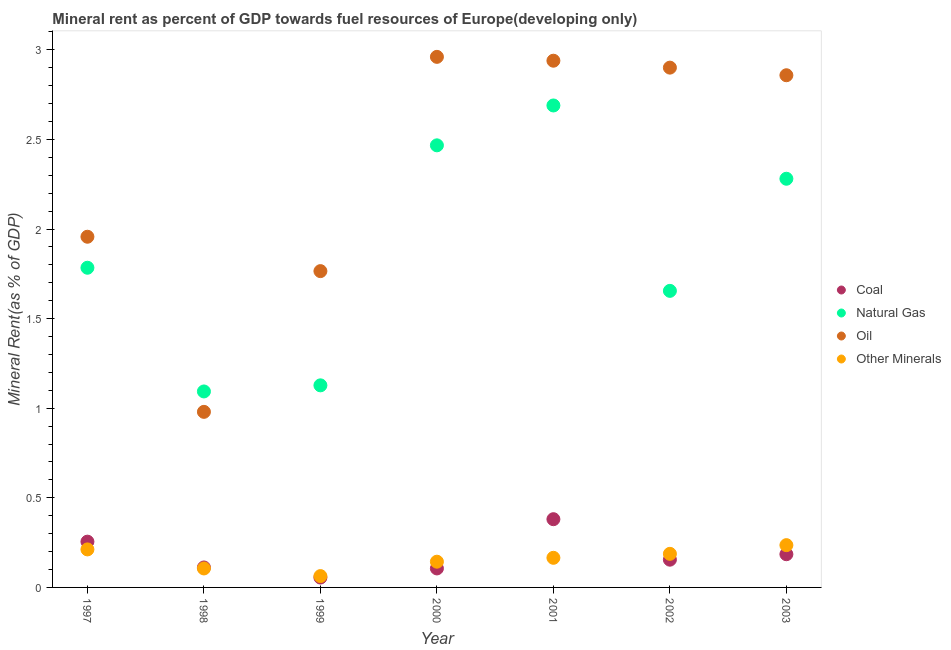How many different coloured dotlines are there?
Your answer should be very brief. 4. Is the number of dotlines equal to the number of legend labels?
Keep it short and to the point. Yes. What is the natural gas rent in 1999?
Offer a very short reply. 1.13. Across all years, what is the maximum coal rent?
Keep it short and to the point. 0.38. Across all years, what is the minimum coal rent?
Your response must be concise. 0.06. In which year was the natural gas rent maximum?
Your answer should be very brief. 2001. What is the total natural gas rent in the graph?
Ensure brevity in your answer.  13.1. What is the difference between the coal rent in 1998 and that in 2001?
Your response must be concise. -0.27. What is the difference between the coal rent in 1999 and the natural gas rent in 2002?
Your answer should be very brief. -1.6. What is the average coal rent per year?
Your response must be concise. 0.18. In the year 2002, what is the difference between the coal rent and oil rent?
Ensure brevity in your answer.  -2.75. In how many years, is the oil rent greater than 0.2 %?
Your answer should be very brief. 7. What is the ratio of the natural gas rent in 1999 to that in 2001?
Offer a very short reply. 0.42. Is the difference between the coal rent in 1998 and 2002 greater than the difference between the oil rent in 1998 and 2002?
Offer a very short reply. Yes. What is the difference between the highest and the second highest natural gas rent?
Provide a succinct answer. 0.22. What is the difference between the highest and the lowest  rent of other minerals?
Your response must be concise. 0.17. Is it the case that in every year, the sum of the coal rent and natural gas rent is greater than the sum of oil rent and  rent of other minerals?
Provide a succinct answer. No. Does the coal rent monotonically increase over the years?
Offer a terse response. No. What is the difference between two consecutive major ticks on the Y-axis?
Make the answer very short. 0.5. Are the values on the major ticks of Y-axis written in scientific E-notation?
Provide a succinct answer. No. Does the graph contain any zero values?
Offer a terse response. No. What is the title of the graph?
Keep it short and to the point. Mineral rent as percent of GDP towards fuel resources of Europe(developing only). Does "Agriculture" appear as one of the legend labels in the graph?
Your answer should be compact. No. What is the label or title of the X-axis?
Offer a very short reply. Year. What is the label or title of the Y-axis?
Provide a succinct answer. Mineral Rent(as % of GDP). What is the Mineral Rent(as % of GDP) of Coal in 1997?
Provide a short and direct response. 0.26. What is the Mineral Rent(as % of GDP) in Natural Gas in 1997?
Your answer should be compact. 1.78. What is the Mineral Rent(as % of GDP) in Oil in 1997?
Keep it short and to the point. 1.96. What is the Mineral Rent(as % of GDP) in Other Minerals in 1997?
Your response must be concise. 0.21. What is the Mineral Rent(as % of GDP) in Coal in 1998?
Provide a succinct answer. 0.11. What is the Mineral Rent(as % of GDP) in Natural Gas in 1998?
Ensure brevity in your answer.  1.09. What is the Mineral Rent(as % of GDP) in Oil in 1998?
Offer a very short reply. 0.98. What is the Mineral Rent(as % of GDP) of Other Minerals in 1998?
Your answer should be compact. 0.11. What is the Mineral Rent(as % of GDP) in Coal in 1999?
Your answer should be compact. 0.06. What is the Mineral Rent(as % of GDP) in Natural Gas in 1999?
Ensure brevity in your answer.  1.13. What is the Mineral Rent(as % of GDP) in Oil in 1999?
Ensure brevity in your answer.  1.77. What is the Mineral Rent(as % of GDP) of Other Minerals in 1999?
Make the answer very short. 0.06. What is the Mineral Rent(as % of GDP) of Coal in 2000?
Your answer should be compact. 0.11. What is the Mineral Rent(as % of GDP) in Natural Gas in 2000?
Ensure brevity in your answer.  2.47. What is the Mineral Rent(as % of GDP) in Oil in 2000?
Ensure brevity in your answer.  2.96. What is the Mineral Rent(as % of GDP) in Other Minerals in 2000?
Offer a terse response. 0.14. What is the Mineral Rent(as % of GDP) in Coal in 2001?
Make the answer very short. 0.38. What is the Mineral Rent(as % of GDP) in Natural Gas in 2001?
Your answer should be very brief. 2.69. What is the Mineral Rent(as % of GDP) of Oil in 2001?
Offer a terse response. 2.94. What is the Mineral Rent(as % of GDP) in Other Minerals in 2001?
Your response must be concise. 0.17. What is the Mineral Rent(as % of GDP) in Coal in 2002?
Provide a short and direct response. 0.15. What is the Mineral Rent(as % of GDP) in Natural Gas in 2002?
Keep it short and to the point. 1.65. What is the Mineral Rent(as % of GDP) of Oil in 2002?
Offer a terse response. 2.9. What is the Mineral Rent(as % of GDP) in Other Minerals in 2002?
Ensure brevity in your answer.  0.19. What is the Mineral Rent(as % of GDP) of Coal in 2003?
Offer a terse response. 0.19. What is the Mineral Rent(as % of GDP) of Natural Gas in 2003?
Give a very brief answer. 2.28. What is the Mineral Rent(as % of GDP) of Oil in 2003?
Provide a short and direct response. 2.86. What is the Mineral Rent(as % of GDP) of Other Minerals in 2003?
Your response must be concise. 0.24. Across all years, what is the maximum Mineral Rent(as % of GDP) of Coal?
Make the answer very short. 0.38. Across all years, what is the maximum Mineral Rent(as % of GDP) in Natural Gas?
Offer a terse response. 2.69. Across all years, what is the maximum Mineral Rent(as % of GDP) of Oil?
Give a very brief answer. 2.96. Across all years, what is the maximum Mineral Rent(as % of GDP) in Other Minerals?
Your answer should be very brief. 0.24. Across all years, what is the minimum Mineral Rent(as % of GDP) of Coal?
Your answer should be very brief. 0.06. Across all years, what is the minimum Mineral Rent(as % of GDP) in Natural Gas?
Offer a terse response. 1.09. Across all years, what is the minimum Mineral Rent(as % of GDP) of Oil?
Your answer should be very brief. 0.98. Across all years, what is the minimum Mineral Rent(as % of GDP) of Other Minerals?
Provide a short and direct response. 0.06. What is the total Mineral Rent(as % of GDP) of Coal in the graph?
Your response must be concise. 1.25. What is the total Mineral Rent(as % of GDP) of Natural Gas in the graph?
Your answer should be very brief. 13.1. What is the total Mineral Rent(as % of GDP) of Oil in the graph?
Ensure brevity in your answer.  16.36. What is the total Mineral Rent(as % of GDP) of Other Minerals in the graph?
Offer a terse response. 1.11. What is the difference between the Mineral Rent(as % of GDP) in Coal in 1997 and that in 1998?
Provide a succinct answer. 0.14. What is the difference between the Mineral Rent(as % of GDP) in Natural Gas in 1997 and that in 1998?
Your response must be concise. 0.69. What is the difference between the Mineral Rent(as % of GDP) of Oil in 1997 and that in 1998?
Offer a very short reply. 0.98. What is the difference between the Mineral Rent(as % of GDP) in Other Minerals in 1997 and that in 1998?
Your answer should be compact. 0.11. What is the difference between the Mineral Rent(as % of GDP) in Coal in 1997 and that in 1999?
Keep it short and to the point. 0.2. What is the difference between the Mineral Rent(as % of GDP) of Natural Gas in 1997 and that in 1999?
Offer a terse response. 0.66. What is the difference between the Mineral Rent(as % of GDP) in Oil in 1997 and that in 1999?
Make the answer very short. 0.19. What is the difference between the Mineral Rent(as % of GDP) in Other Minerals in 1997 and that in 1999?
Your answer should be compact. 0.15. What is the difference between the Mineral Rent(as % of GDP) in Coal in 1997 and that in 2000?
Ensure brevity in your answer.  0.15. What is the difference between the Mineral Rent(as % of GDP) of Natural Gas in 1997 and that in 2000?
Keep it short and to the point. -0.68. What is the difference between the Mineral Rent(as % of GDP) in Oil in 1997 and that in 2000?
Offer a very short reply. -1. What is the difference between the Mineral Rent(as % of GDP) of Other Minerals in 1997 and that in 2000?
Your answer should be very brief. 0.07. What is the difference between the Mineral Rent(as % of GDP) of Coal in 1997 and that in 2001?
Make the answer very short. -0.13. What is the difference between the Mineral Rent(as % of GDP) of Natural Gas in 1997 and that in 2001?
Make the answer very short. -0.91. What is the difference between the Mineral Rent(as % of GDP) in Oil in 1997 and that in 2001?
Provide a short and direct response. -0.98. What is the difference between the Mineral Rent(as % of GDP) of Other Minerals in 1997 and that in 2001?
Offer a terse response. 0.05. What is the difference between the Mineral Rent(as % of GDP) of Coal in 1997 and that in 2002?
Your answer should be very brief. 0.1. What is the difference between the Mineral Rent(as % of GDP) of Natural Gas in 1997 and that in 2002?
Your response must be concise. 0.13. What is the difference between the Mineral Rent(as % of GDP) of Oil in 1997 and that in 2002?
Ensure brevity in your answer.  -0.94. What is the difference between the Mineral Rent(as % of GDP) of Other Minerals in 1997 and that in 2002?
Provide a short and direct response. 0.02. What is the difference between the Mineral Rent(as % of GDP) in Coal in 1997 and that in 2003?
Keep it short and to the point. 0.07. What is the difference between the Mineral Rent(as % of GDP) of Natural Gas in 1997 and that in 2003?
Your response must be concise. -0.5. What is the difference between the Mineral Rent(as % of GDP) of Oil in 1997 and that in 2003?
Offer a very short reply. -0.9. What is the difference between the Mineral Rent(as % of GDP) of Other Minerals in 1997 and that in 2003?
Offer a terse response. -0.02. What is the difference between the Mineral Rent(as % of GDP) of Coal in 1998 and that in 1999?
Your answer should be very brief. 0.06. What is the difference between the Mineral Rent(as % of GDP) in Natural Gas in 1998 and that in 1999?
Provide a succinct answer. -0.03. What is the difference between the Mineral Rent(as % of GDP) in Oil in 1998 and that in 1999?
Provide a succinct answer. -0.79. What is the difference between the Mineral Rent(as % of GDP) in Other Minerals in 1998 and that in 1999?
Make the answer very short. 0.04. What is the difference between the Mineral Rent(as % of GDP) of Coal in 1998 and that in 2000?
Your answer should be very brief. 0.01. What is the difference between the Mineral Rent(as % of GDP) of Natural Gas in 1998 and that in 2000?
Keep it short and to the point. -1.37. What is the difference between the Mineral Rent(as % of GDP) in Oil in 1998 and that in 2000?
Your answer should be compact. -1.98. What is the difference between the Mineral Rent(as % of GDP) of Other Minerals in 1998 and that in 2000?
Offer a terse response. -0.04. What is the difference between the Mineral Rent(as % of GDP) in Coal in 1998 and that in 2001?
Your answer should be very brief. -0.27. What is the difference between the Mineral Rent(as % of GDP) of Natural Gas in 1998 and that in 2001?
Your response must be concise. -1.6. What is the difference between the Mineral Rent(as % of GDP) in Oil in 1998 and that in 2001?
Offer a very short reply. -1.96. What is the difference between the Mineral Rent(as % of GDP) of Other Minerals in 1998 and that in 2001?
Provide a succinct answer. -0.06. What is the difference between the Mineral Rent(as % of GDP) of Coal in 1998 and that in 2002?
Offer a very short reply. -0.04. What is the difference between the Mineral Rent(as % of GDP) in Natural Gas in 1998 and that in 2002?
Give a very brief answer. -0.56. What is the difference between the Mineral Rent(as % of GDP) of Oil in 1998 and that in 2002?
Give a very brief answer. -1.92. What is the difference between the Mineral Rent(as % of GDP) of Other Minerals in 1998 and that in 2002?
Provide a succinct answer. -0.08. What is the difference between the Mineral Rent(as % of GDP) of Coal in 1998 and that in 2003?
Your response must be concise. -0.07. What is the difference between the Mineral Rent(as % of GDP) in Natural Gas in 1998 and that in 2003?
Provide a short and direct response. -1.19. What is the difference between the Mineral Rent(as % of GDP) of Oil in 1998 and that in 2003?
Give a very brief answer. -1.88. What is the difference between the Mineral Rent(as % of GDP) in Other Minerals in 1998 and that in 2003?
Offer a very short reply. -0.13. What is the difference between the Mineral Rent(as % of GDP) of Coal in 1999 and that in 2000?
Provide a short and direct response. -0.05. What is the difference between the Mineral Rent(as % of GDP) in Natural Gas in 1999 and that in 2000?
Your answer should be compact. -1.34. What is the difference between the Mineral Rent(as % of GDP) of Oil in 1999 and that in 2000?
Offer a very short reply. -1.2. What is the difference between the Mineral Rent(as % of GDP) of Other Minerals in 1999 and that in 2000?
Your answer should be compact. -0.08. What is the difference between the Mineral Rent(as % of GDP) in Coal in 1999 and that in 2001?
Ensure brevity in your answer.  -0.33. What is the difference between the Mineral Rent(as % of GDP) in Natural Gas in 1999 and that in 2001?
Give a very brief answer. -1.56. What is the difference between the Mineral Rent(as % of GDP) of Oil in 1999 and that in 2001?
Offer a terse response. -1.17. What is the difference between the Mineral Rent(as % of GDP) in Other Minerals in 1999 and that in 2001?
Your answer should be compact. -0.1. What is the difference between the Mineral Rent(as % of GDP) in Coal in 1999 and that in 2002?
Give a very brief answer. -0.1. What is the difference between the Mineral Rent(as % of GDP) in Natural Gas in 1999 and that in 2002?
Provide a succinct answer. -0.53. What is the difference between the Mineral Rent(as % of GDP) of Oil in 1999 and that in 2002?
Your response must be concise. -1.14. What is the difference between the Mineral Rent(as % of GDP) in Other Minerals in 1999 and that in 2002?
Provide a succinct answer. -0.12. What is the difference between the Mineral Rent(as % of GDP) of Coal in 1999 and that in 2003?
Your answer should be very brief. -0.13. What is the difference between the Mineral Rent(as % of GDP) in Natural Gas in 1999 and that in 2003?
Your answer should be compact. -1.15. What is the difference between the Mineral Rent(as % of GDP) of Oil in 1999 and that in 2003?
Your response must be concise. -1.09. What is the difference between the Mineral Rent(as % of GDP) in Other Minerals in 1999 and that in 2003?
Your response must be concise. -0.17. What is the difference between the Mineral Rent(as % of GDP) in Coal in 2000 and that in 2001?
Your answer should be compact. -0.27. What is the difference between the Mineral Rent(as % of GDP) of Natural Gas in 2000 and that in 2001?
Your response must be concise. -0.22. What is the difference between the Mineral Rent(as % of GDP) in Oil in 2000 and that in 2001?
Offer a very short reply. 0.02. What is the difference between the Mineral Rent(as % of GDP) of Other Minerals in 2000 and that in 2001?
Ensure brevity in your answer.  -0.02. What is the difference between the Mineral Rent(as % of GDP) of Coal in 2000 and that in 2002?
Offer a terse response. -0.05. What is the difference between the Mineral Rent(as % of GDP) of Natural Gas in 2000 and that in 2002?
Provide a succinct answer. 0.81. What is the difference between the Mineral Rent(as % of GDP) of Oil in 2000 and that in 2002?
Your answer should be very brief. 0.06. What is the difference between the Mineral Rent(as % of GDP) in Other Minerals in 2000 and that in 2002?
Your answer should be compact. -0.04. What is the difference between the Mineral Rent(as % of GDP) of Coal in 2000 and that in 2003?
Make the answer very short. -0.08. What is the difference between the Mineral Rent(as % of GDP) in Natural Gas in 2000 and that in 2003?
Offer a terse response. 0.19. What is the difference between the Mineral Rent(as % of GDP) of Oil in 2000 and that in 2003?
Provide a short and direct response. 0.1. What is the difference between the Mineral Rent(as % of GDP) in Other Minerals in 2000 and that in 2003?
Ensure brevity in your answer.  -0.09. What is the difference between the Mineral Rent(as % of GDP) in Coal in 2001 and that in 2002?
Keep it short and to the point. 0.23. What is the difference between the Mineral Rent(as % of GDP) in Natural Gas in 2001 and that in 2002?
Keep it short and to the point. 1.03. What is the difference between the Mineral Rent(as % of GDP) in Oil in 2001 and that in 2002?
Provide a succinct answer. 0.04. What is the difference between the Mineral Rent(as % of GDP) in Other Minerals in 2001 and that in 2002?
Provide a succinct answer. -0.02. What is the difference between the Mineral Rent(as % of GDP) in Coal in 2001 and that in 2003?
Offer a terse response. 0.2. What is the difference between the Mineral Rent(as % of GDP) of Natural Gas in 2001 and that in 2003?
Keep it short and to the point. 0.41. What is the difference between the Mineral Rent(as % of GDP) of Oil in 2001 and that in 2003?
Make the answer very short. 0.08. What is the difference between the Mineral Rent(as % of GDP) in Other Minerals in 2001 and that in 2003?
Provide a succinct answer. -0.07. What is the difference between the Mineral Rent(as % of GDP) of Coal in 2002 and that in 2003?
Your response must be concise. -0.03. What is the difference between the Mineral Rent(as % of GDP) of Natural Gas in 2002 and that in 2003?
Your answer should be very brief. -0.63. What is the difference between the Mineral Rent(as % of GDP) in Oil in 2002 and that in 2003?
Your answer should be very brief. 0.04. What is the difference between the Mineral Rent(as % of GDP) in Other Minerals in 2002 and that in 2003?
Offer a terse response. -0.05. What is the difference between the Mineral Rent(as % of GDP) in Coal in 1997 and the Mineral Rent(as % of GDP) in Natural Gas in 1998?
Offer a very short reply. -0.84. What is the difference between the Mineral Rent(as % of GDP) in Coal in 1997 and the Mineral Rent(as % of GDP) in Oil in 1998?
Provide a succinct answer. -0.72. What is the difference between the Mineral Rent(as % of GDP) in Coal in 1997 and the Mineral Rent(as % of GDP) in Other Minerals in 1998?
Provide a succinct answer. 0.15. What is the difference between the Mineral Rent(as % of GDP) in Natural Gas in 1997 and the Mineral Rent(as % of GDP) in Oil in 1998?
Offer a very short reply. 0.8. What is the difference between the Mineral Rent(as % of GDP) in Natural Gas in 1997 and the Mineral Rent(as % of GDP) in Other Minerals in 1998?
Your answer should be very brief. 1.68. What is the difference between the Mineral Rent(as % of GDP) of Oil in 1997 and the Mineral Rent(as % of GDP) of Other Minerals in 1998?
Offer a terse response. 1.85. What is the difference between the Mineral Rent(as % of GDP) in Coal in 1997 and the Mineral Rent(as % of GDP) in Natural Gas in 1999?
Provide a succinct answer. -0.87. What is the difference between the Mineral Rent(as % of GDP) of Coal in 1997 and the Mineral Rent(as % of GDP) of Oil in 1999?
Ensure brevity in your answer.  -1.51. What is the difference between the Mineral Rent(as % of GDP) in Coal in 1997 and the Mineral Rent(as % of GDP) in Other Minerals in 1999?
Give a very brief answer. 0.19. What is the difference between the Mineral Rent(as % of GDP) of Natural Gas in 1997 and the Mineral Rent(as % of GDP) of Oil in 1999?
Your response must be concise. 0.02. What is the difference between the Mineral Rent(as % of GDP) in Natural Gas in 1997 and the Mineral Rent(as % of GDP) in Other Minerals in 1999?
Provide a succinct answer. 1.72. What is the difference between the Mineral Rent(as % of GDP) in Oil in 1997 and the Mineral Rent(as % of GDP) in Other Minerals in 1999?
Ensure brevity in your answer.  1.89. What is the difference between the Mineral Rent(as % of GDP) of Coal in 1997 and the Mineral Rent(as % of GDP) of Natural Gas in 2000?
Give a very brief answer. -2.21. What is the difference between the Mineral Rent(as % of GDP) in Coal in 1997 and the Mineral Rent(as % of GDP) in Oil in 2000?
Offer a terse response. -2.71. What is the difference between the Mineral Rent(as % of GDP) of Coal in 1997 and the Mineral Rent(as % of GDP) of Other Minerals in 2000?
Your answer should be very brief. 0.11. What is the difference between the Mineral Rent(as % of GDP) in Natural Gas in 1997 and the Mineral Rent(as % of GDP) in Oil in 2000?
Your answer should be very brief. -1.18. What is the difference between the Mineral Rent(as % of GDP) in Natural Gas in 1997 and the Mineral Rent(as % of GDP) in Other Minerals in 2000?
Provide a succinct answer. 1.64. What is the difference between the Mineral Rent(as % of GDP) of Oil in 1997 and the Mineral Rent(as % of GDP) of Other Minerals in 2000?
Your answer should be very brief. 1.81. What is the difference between the Mineral Rent(as % of GDP) of Coal in 1997 and the Mineral Rent(as % of GDP) of Natural Gas in 2001?
Provide a short and direct response. -2.43. What is the difference between the Mineral Rent(as % of GDP) of Coal in 1997 and the Mineral Rent(as % of GDP) of Oil in 2001?
Your response must be concise. -2.68. What is the difference between the Mineral Rent(as % of GDP) in Coal in 1997 and the Mineral Rent(as % of GDP) in Other Minerals in 2001?
Give a very brief answer. 0.09. What is the difference between the Mineral Rent(as % of GDP) of Natural Gas in 1997 and the Mineral Rent(as % of GDP) of Oil in 2001?
Your answer should be very brief. -1.16. What is the difference between the Mineral Rent(as % of GDP) of Natural Gas in 1997 and the Mineral Rent(as % of GDP) of Other Minerals in 2001?
Your answer should be compact. 1.62. What is the difference between the Mineral Rent(as % of GDP) of Oil in 1997 and the Mineral Rent(as % of GDP) of Other Minerals in 2001?
Provide a short and direct response. 1.79. What is the difference between the Mineral Rent(as % of GDP) of Coal in 1997 and the Mineral Rent(as % of GDP) of Natural Gas in 2002?
Offer a terse response. -1.4. What is the difference between the Mineral Rent(as % of GDP) of Coal in 1997 and the Mineral Rent(as % of GDP) of Oil in 2002?
Keep it short and to the point. -2.65. What is the difference between the Mineral Rent(as % of GDP) of Coal in 1997 and the Mineral Rent(as % of GDP) of Other Minerals in 2002?
Keep it short and to the point. 0.07. What is the difference between the Mineral Rent(as % of GDP) of Natural Gas in 1997 and the Mineral Rent(as % of GDP) of Oil in 2002?
Provide a short and direct response. -1.12. What is the difference between the Mineral Rent(as % of GDP) of Natural Gas in 1997 and the Mineral Rent(as % of GDP) of Other Minerals in 2002?
Make the answer very short. 1.6. What is the difference between the Mineral Rent(as % of GDP) of Oil in 1997 and the Mineral Rent(as % of GDP) of Other Minerals in 2002?
Make the answer very short. 1.77. What is the difference between the Mineral Rent(as % of GDP) of Coal in 1997 and the Mineral Rent(as % of GDP) of Natural Gas in 2003?
Give a very brief answer. -2.03. What is the difference between the Mineral Rent(as % of GDP) in Coal in 1997 and the Mineral Rent(as % of GDP) in Oil in 2003?
Your answer should be very brief. -2.6. What is the difference between the Mineral Rent(as % of GDP) of Coal in 1997 and the Mineral Rent(as % of GDP) of Other Minerals in 2003?
Keep it short and to the point. 0.02. What is the difference between the Mineral Rent(as % of GDP) in Natural Gas in 1997 and the Mineral Rent(as % of GDP) in Oil in 2003?
Provide a succinct answer. -1.07. What is the difference between the Mineral Rent(as % of GDP) in Natural Gas in 1997 and the Mineral Rent(as % of GDP) in Other Minerals in 2003?
Your answer should be very brief. 1.55. What is the difference between the Mineral Rent(as % of GDP) of Oil in 1997 and the Mineral Rent(as % of GDP) of Other Minerals in 2003?
Keep it short and to the point. 1.72. What is the difference between the Mineral Rent(as % of GDP) in Coal in 1998 and the Mineral Rent(as % of GDP) in Natural Gas in 1999?
Your response must be concise. -1.02. What is the difference between the Mineral Rent(as % of GDP) of Coal in 1998 and the Mineral Rent(as % of GDP) of Oil in 1999?
Offer a terse response. -1.65. What is the difference between the Mineral Rent(as % of GDP) of Coal in 1998 and the Mineral Rent(as % of GDP) of Other Minerals in 1999?
Give a very brief answer. 0.05. What is the difference between the Mineral Rent(as % of GDP) of Natural Gas in 1998 and the Mineral Rent(as % of GDP) of Oil in 1999?
Your answer should be very brief. -0.67. What is the difference between the Mineral Rent(as % of GDP) of Natural Gas in 1998 and the Mineral Rent(as % of GDP) of Other Minerals in 1999?
Your answer should be compact. 1.03. What is the difference between the Mineral Rent(as % of GDP) in Oil in 1998 and the Mineral Rent(as % of GDP) in Other Minerals in 1999?
Your response must be concise. 0.92. What is the difference between the Mineral Rent(as % of GDP) of Coal in 1998 and the Mineral Rent(as % of GDP) of Natural Gas in 2000?
Keep it short and to the point. -2.36. What is the difference between the Mineral Rent(as % of GDP) in Coal in 1998 and the Mineral Rent(as % of GDP) in Oil in 2000?
Offer a terse response. -2.85. What is the difference between the Mineral Rent(as % of GDP) of Coal in 1998 and the Mineral Rent(as % of GDP) of Other Minerals in 2000?
Your response must be concise. -0.03. What is the difference between the Mineral Rent(as % of GDP) of Natural Gas in 1998 and the Mineral Rent(as % of GDP) of Oil in 2000?
Give a very brief answer. -1.87. What is the difference between the Mineral Rent(as % of GDP) of Oil in 1998 and the Mineral Rent(as % of GDP) of Other Minerals in 2000?
Make the answer very short. 0.84. What is the difference between the Mineral Rent(as % of GDP) in Coal in 1998 and the Mineral Rent(as % of GDP) in Natural Gas in 2001?
Provide a succinct answer. -2.58. What is the difference between the Mineral Rent(as % of GDP) of Coal in 1998 and the Mineral Rent(as % of GDP) of Oil in 2001?
Offer a terse response. -2.83. What is the difference between the Mineral Rent(as % of GDP) in Coal in 1998 and the Mineral Rent(as % of GDP) in Other Minerals in 2001?
Your answer should be very brief. -0.05. What is the difference between the Mineral Rent(as % of GDP) of Natural Gas in 1998 and the Mineral Rent(as % of GDP) of Oil in 2001?
Offer a terse response. -1.85. What is the difference between the Mineral Rent(as % of GDP) in Natural Gas in 1998 and the Mineral Rent(as % of GDP) in Other Minerals in 2001?
Keep it short and to the point. 0.93. What is the difference between the Mineral Rent(as % of GDP) of Oil in 1998 and the Mineral Rent(as % of GDP) of Other Minerals in 2001?
Provide a short and direct response. 0.81. What is the difference between the Mineral Rent(as % of GDP) in Coal in 1998 and the Mineral Rent(as % of GDP) in Natural Gas in 2002?
Give a very brief answer. -1.54. What is the difference between the Mineral Rent(as % of GDP) of Coal in 1998 and the Mineral Rent(as % of GDP) of Oil in 2002?
Your answer should be very brief. -2.79. What is the difference between the Mineral Rent(as % of GDP) in Coal in 1998 and the Mineral Rent(as % of GDP) in Other Minerals in 2002?
Provide a short and direct response. -0.08. What is the difference between the Mineral Rent(as % of GDP) of Natural Gas in 1998 and the Mineral Rent(as % of GDP) of Oil in 2002?
Keep it short and to the point. -1.81. What is the difference between the Mineral Rent(as % of GDP) in Natural Gas in 1998 and the Mineral Rent(as % of GDP) in Other Minerals in 2002?
Offer a terse response. 0.91. What is the difference between the Mineral Rent(as % of GDP) in Oil in 1998 and the Mineral Rent(as % of GDP) in Other Minerals in 2002?
Ensure brevity in your answer.  0.79. What is the difference between the Mineral Rent(as % of GDP) of Coal in 1998 and the Mineral Rent(as % of GDP) of Natural Gas in 2003?
Keep it short and to the point. -2.17. What is the difference between the Mineral Rent(as % of GDP) in Coal in 1998 and the Mineral Rent(as % of GDP) in Oil in 2003?
Your answer should be very brief. -2.75. What is the difference between the Mineral Rent(as % of GDP) in Coal in 1998 and the Mineral Rent(as % of GDP) in Other Minerals in 2003?
Offer a terse response. -0.12. What is the difference between the Mineral Rent(as % of GDP) of Natural Gas in 1998 and the Mineral Rent(as % of GDP) of Oil in 2003?
Ensure brevity in your answer.  -1.76. What is the difference between the Mineral Rent(as % of GDP) in Natural Gas in 1998 and the Mineral Rent(as % of GDP) in Other Minerals in 2003?
Provide a short and direct response. 0.86. What is the difference between the Mineral Rent(as % of GDP) of Oil in 1998 and the Mineral Rent(as % of GDP) of Other Minerals in 2003?
Your response must be concise. 0.74. What is the difference between the Mineral Rent(as % of GDP) in Coal in 1999 and the Mineral Rent(as % of GDP) in Natural Gas in 2000?
Offer a terse response. -2.41. What is the difference between the Mineral Rent(as % of GDP) in Coal in 1999 and the Mineral Rent(as % of GDP) in Oil in 2000?
Make the answer very short. -2.91. What is the difference between the Mineral Rent(as % of GDP) of Coal in 1999 and the Mineral Rent(as % of GDP) of Other Minerals in 2000?
Give a very brief answer. -0.09. What is the difference between the Mineral Rent(as % of GDP) of Natural Gas in 1999 and the Mineral Rent(as % of GDP) of Oil in 2000?
Your answer should be compact. -1.83. What is the difference between the Mineral Rent(as % of GDP) of Natural Gas in 1999 and the Mineral Rent(as % of GDP) of Other Minerals in 2000?
Your answer should be very brief. 0.98. What is the difference between the Mineral Rent(as % of GDP) in Oil in 1999 and the Mineral Rent(as % of GDP) in Other Minerals in 2000?
Offer a very short reply. 1.62. What is the difference between the Mineral Rent(as % of GDP) in Coal in 1999 and the Mineral Rent(as % of GDP) in Natural Gas in 2001?
Make the answer very short. -2.63. What is the difference between the Mineral Rent(as % of GDP) of Coal in 1999 and the Mineral Rent(as % of GDP) of Oil in 2001?
Give a very brief answer. -2.88. What is the difference between the Mineral Rent(as % of GDP) in Coal in 1999 and the Mineral Rent(as % of GDP) in Other Minerals in 2001?
Provide a short and direct response. -0.11. What is the difference between the Mineral Rent(as % of GDP) of Natural Gas in 1999 and the Mineral Rent(as % of GDP) of Oil in 2001?
Provide a succinct answer. -1.81. What is the difference between the Mineral Rent(as % of GDP) of Natural Gas in 1999 and the Mineral Rent(as % of GDP) of Other Minerals in 2001?
Your answer should be very brief. 0.96. What is the difference between the Mineral Rent(as % of GDP) in Oil in 1999 and the Mineral Rent(as % of GDP) in Other Minerals in 2001?
Provide a short and direct response. 1.6. What is the difference between the Mineral Rent(as % of GDP) in Coal in 1999 and the Mineral Rent(as % of GDP) in Natural Gas in 2002?
Provide a succinct answer. -1.6. What is the difference between the Mineral Rent(as % of GDP) in Coal in 1999 and the Mineral Rent(as % of GDP) in Oil in 2002?
Offer a terse response. -2.85. What is the difference between the Mineral Rent(as % of GDP) of Coal in 1999 and the Mineral Rent(as % of GDP) of Other Minerals in 2002?
Your response must be concise. -0.13. What is the difference between the Mineral Rent(as % of GDP) in Natural Gas in 1999 and the Mineral Rent(as % of GDP) in Oil in 2002?
Keep it short and to the point. -1.77. What is the difference between the Mineral Rent(as % of GDP) of Natural Gas in 1999 and the Mineral Rent(as % of GDP) of Other Minerals in 2002?
Provide a succinct answer. 0.94. What is the difference between the Mineral Rent(as % of GDP) of Oil in 1999 and the Mineral Rent(as % of GDP) of Other Minerals in 2002?
Your answer should be compact. 1.58. What is the difference between the Mineral Rent(as % of GDP) in Coal in 1999 and the Mineral Rent(as % of GDP) in Natural Gas in 2003?
Ensure brevity in your answer.  -2.23. What is the difference between the Mineral Rent(as % of GDP) in Coal in 1999 and the Mineral Rent(as % of GDP) in Oil in 2003?
Offer a terse response. -2.8. What is the difference between the Mineral Rent(as % of GDP) of Coal in 1999 and the Mineral Rent(as % of GDP) of Other Minerals in 2003?
Provide a succinct answer. -0.18. What is the difference between the Mineral Rent(as % of GDP) of Natural Gas in 1999 and the Mineral Rent(as % of GDP) of Oil in 2003?
Your answer should be very brief. -1.73. What is the difference between the Mineral Rent(as % of GDP) of Natural Gas in 1999 and the Mineral Rent(as % of GDP) of Other Minerals in 2003?
Ensure brevity in your answer.  0.89. What is the difference between the Mineral Rent(as % of GDP) of Oil in 1999 and the Mineral Rent(as % of GDP) of Other Minerals in 2003?
Keep it short and to the point. 1.53. What is the difference between the Mineral Rent(as % of GDP) in Coal in 2000 and the Mineral Rent(as % of GDP) in Natural Gas in 2001?
Keep it short and to the point. -2.58. What is the difference between the Mineral Rent(as % of GDP) in Coal in 2000 and the Mineral Rent(as % of GDP) in Oil in 2001?
Offer a terse response. -2.83. What is the difference between the Mineral Rent(as % of GDP) in Coal in 2000 and the Mineral Rent(as % of GDP) in Other Minerals in 2001?
Provide a succinct answer. -0.06. What is the difference between the Mineral Rent(as % of GDP) of Natural Gas in 2000 and the Mineral Rent(as % of GDP) of Oil in 2001?
Your response must be concise. -0.47. What is the difference between the Mineral Rent(as % of GDP) in Natural Gas in 2000 and the Mineral Rent(as % of GDP) in Other Minerals in 2001?
Provide a short and direct response. 2.3. What is the difference between the Mineral Rent(as % of GDP) in Oil in 2000 and the Mineral Rent(as % of GDP) in Other Minerals in 2001?
Your answer should be compact. 2.8. What is the difference between the Mineral Rent(as % of GDP) of Coal in 2000 and the Mineral Rent(as % of GDP) of Natural Gas in 2002?
Make the answer very short. -1.55. What is the difference between the Mineral Rent(as % of GDP) in Coal in 2000 and the Mineral Rent(as % of GDP) in Oil in 2002?
Make the answer very short. -2.79. What is the difference between the Mineral Rent(as % of GDP) in Coal in 2000 and the Mineral Rent(as % of GDP) in Other Minerals in 2002?
Provide a short and direct response. -0.08. What is the difference between the Mineral Rent(as % of GDP) of Natural Gas in 2000 and the Mineral Rent(as % of GDP) of Oil in 2002?
Provide a short and direct response. -0.43. What is the difference between the Mineral Rent(as % of GDP) in Natural Gas in 2000 and the Mineral Rent(as % of GDP) in Other Minerals in 2002?
Keep it short and to the point. 2.28. What is the difference between the Mineral Rent(as % of GDP) of Oil in 2000 and the Mineral Rent(as % of GDP) of Other Minerals in 2002?
Offer a terse response. 2.77. What is the difference between the Mineral Rent(as % of GDP) of Coal in 2000 and the Mineral Rent(as % of GDP) of Natural Gas in 2003?
Your answer should be very brief. -2.17. What is the difference between the Mineral Rent(as % of GDP) in Coal in 2000 and the Mineral Rent(as % of GDP) in Oil in 2003?
Your response must be concise. -2.75. What is the difference between the Mineral Rent(as % of GDP) in Coal in 2000 and the Mineral Rent(as % of GDP) in Other Minerals in 2003?
Your answer should be very brief. -0.13. What is the difference between the Mineral Rent(as % of GDP) in Natural Gas in 2000 and the Mineral Rent(as % of GDP) in Oil in 2003?
Provide a short and direct response. -0.39. What is the difference between the Mineral Rent(as % of GDP) in Natural Gas in 2000 and the Mineral Rent(as % of GDP) in Other Minerals in 2003?
Your answer should be very brief. 2.23. What is the difference between the Mineral Rent(as % of GDP) of Oil in 2000 and the Mineral Rent(as % of GDP) of Other Minerals in 2003?
Make the answer very short. 2.72. What is the difference between the Mineral Rent(as % of GDP) of Coal in 2001 and the Mineral Rent(as % of GDP) of Natural Gas in 2002?
Offer a very short reply. -1.27. What is the difference between the Mineral Rent(as % of GDP) of Coal in 2001 and the Mineral Rent(as % of GDP) of Oil in 2002?
Keep it short and to the point. -2.52. What is the difference between the Mineral Rent(as % of GDP) of Coal in 2001 and the Mineral Rent(as % of GDP) of Other Minerals in 2002?
Give a very brief answer. 0.19. What is the difference between the Mineral Rent(as % of GDP) in Natural Gas in 2001 and the Mineral Rent(as % of GDP) in Oil in 2002?
Provide a succinct answer. -0.21. What is the difference between the Mineral Rent(as % of GDP) in Natural Gas in 2001 and the Mineral Rent(as % of GDP) in Other Minerals in 2002?
Your answer should be compact. 2.5. What is the difference between the Mineral Rent(as % of GDP) in Oil in 2001 and the Mineral Rent(as % of GDP) in Other Minerals in 2002?
Offer a terse response. 2.75. What is the difference between the Mineral Rent(as % of GDP) in Coal in 2001 and the Mineral Rent(as % of GDP) in Natural Gas in 2003?
Keep it short and to the point. -1.9. What is the difference between the Mineral Rent(as % of GDP) of Coal in 2001 and the Mineral Rent(as % of GDP) of Oil in 2003?
Your answer should be very brief. -2.48. What is the difference between the Mineral Rent(as % of GDP) of Coal in 2001 and the Mineral Rent(as % of GDP) of Other Minerals in 2003?
Provide a short and direct response. 0.14. What is the difference between the Mineral Rent(as % of GDP) of Natural Gas in 2001 and the Mineral Rent(as % of GDP) of Oil in 2003?
Ensure brevity in your answer.  -0.17. What is the difference between the Mineral Rent(as % of GDP) in Natural Gas in 2001 and the Mineral Rent(as % of GDP) in Other Minerals in 2003?
Offer a terse response. 2.45. What is the difference between the Mineral Rent(as % of GDP) of Oil in 2001 and the Mineral Rent(as % of GDP) of Other Minerals in 2003?
Your answer should be compact. 2.7. What is the difference between the Mineral Rent(as % of GDP) in Coal in 2002 and the Mineral Rent(as % of GDP) in Natural Gas in 2003?
Your answer should be very brief. -2.13. What is the difference between the Mineral Rent(as % of GDP) in Coal in 2002 and the Mineral Rent(as % of GDP) in Oil in 2003?
Your response must be concise. -2.7. What is the difference between the Mineral Rent(as % of GDP) of Coal in 2002 and the Mineral Rent(as % of GDP) of Other Minerals in 2003?
Provide a succinct answer. -0.08. What is the difference between the Mineral Rent(as % of GDP) of Natural Gas in 2002 and the Mineral Rent(as % of GDP) of Oil in 2003?
Provide a short and direct response. -1.2. What is the difference between the Mineral Rent(as % of GDP) in Natural Gas in 2002 and the Mineral Rent(as % of GDP) in Other Minerals in 2003?
Provide a short and direct response. 1.42. What is the difference between the Mineral Rent(as % of GDP) in Oil in 2002 and the Mineral Rent(as % of GDP) in Other Minerals in 2003?
Offer a very short reply. 2.66. What is the average Mineral Rent(as % of GDP) in Coal per year?
Offer a terse response. 0.18. What is the average Mineral Rent(as % of GDP) in Natural Gas per year?
Provide a short and direct response. 1.87. What is the average Mineral Rent(as % of GDP) in Oil per year?
Offer a terse response. 2.34. What is the average Mineral Rent(as % of GDP) of Other Minerals per year?
Your answer should be very brief. 0.16. In the year 1997, what is the difference between the Mineral Rent(as % of GDP) of Coal and Mineral Rent(as % of GDP) of Natural Gas?
Give a very brief answer. -1.53. In the year 1997, what is the difference between the Mineral Rent(as % of GDP) in Coal and Mineral Rent(as % of GDP) in Oil?
Offer a very short reply. -1.7. In the year 1997, what is the difference between the Mineral Rent(as % of GDP) of Coal and Mineral Rent(as % of GDP) of Other Minerals?
Make the answer very short. 0.04. In the year 1997, what is the difference between the Mineral Rent(as % of GDP) in Natural Gas and Mineral Rent(as % of GDP) in Oil?
Provide a short and direct response. -0.17. In the year 1997, what is the difference between the Mineral Rent(as % of GDP) in Natural Gas and Mineral Rent(as % of GDP) in Other Minerals?
Keep it short and to the point. 1.57. In the year 1997, what is the difference between the Mineral Rent(as % of GDP) in Oil and Mineral Rent(as % of GDP) in Other Minerals?
Your response must be concise. 1.74. In the year 1998, what is the difference between the Mineral Rent(as % of GDP) of Coal and Mineral Rent(as % of GDP) of Natural Gas?
Ensure brevity in your answer.  -0.98. In the year 1998, what is the difference between the Mineral Rent(as % of GDP) in Coal and Mineral Rent(as % of GDP) in Oil?
Make the answer very short. -0.87. In the year 1998, what is the difference between the Mineral Rent(as % of GDP) in Coal and Mineral Rent(as % of GDP) in Other Minerals?
Ensure brevity in your answer.  0.01. In the year 1998, what is the difference between the Mineral Rent(as % of GDP) of Natural Gas and Mineral Rent(as % of GDP) of Oil?
Offer a very short reply. 0.11. In the year 1998, what is the difference between the Mineral Rent(as % of GDP) in Natural Gas and Mineral Rent(as % of GDP) in Other Minerals?
Your answer should be compact. 0.99. In the year 1998, what is the difference between the Mineral Rent(as % of GDP) of Oil and Mineral Rent(as % of GDP) of Other Minerals?
Make the answer very short. 0.87. In the year 1999, what is the difference between the Mineral Rent(as % of GDP) in Coal and Mineral Rent(as % of GDP) in Natural Gas?
Provide a succinct answer. -1.07. In the year 1999, what is the difference between the Mineral Rent(as % of GDP) of Coal and Mineral Rent(as % of GDP) of Oil?
Your answer should be very brief. -1.71. In the year 1999, what is the difference between the Mineral Rent(as % of GDP) in Coal and Mineral Rent(as % of GDP) in Other Minerals?
Your response must be concise. -0.01. In the year 1999, what is the difference between the Mineral Rent(as % of GDP) of Natural Gas and Mineral Rent(as % of GDP) of Oil?
Provide a succinct answer. -0.64. In the year 1999, what is the difference between the Mineral Rent(as % of GDP) of Natural Gas and Mineral Rent(as % of GDP) of Other Minerals?
Your answer should be compact. 1.06. In the year 1999, what is the difference between the Mineral Rent(as % of GDP) of Oil and Mineral Rent(as % of GDP) of Other Minerals?
Provide a succinct answer. 1.7. In the year 2000, what is the difference between the Mineral Rent(as % of GDP) of Coal and Mineral Rent(as % of GDP) of Natural Gas?
Your response must be concise. -2.36. In the year 2000, what is the difference between the Mineral Rent(as % of GDP) of Coal and Mineral Rent(as % of GDP) of Oil?
Your answer should be compact. -2.85. In the year 2000, what is the difference between the Mineral Rent(as % of GDP) of Coal and Mineral Rent(as % of GDP) of Other Minerals?
Provide a short and direct response. -0.04. In the year 2000, what is the difference between the Mineral Rent(as % of GDP) of Natural Gas and Mineral Rent(as % of GDP) of Oil?
Your answer should be very brief. -0.49. In the year 2000, what is the difference between the Mineral Rent(as % of GDP) of Natural Gas and Mineral Rent(as % of GDP) of Other Minerals?
Provide a succinct answer. 2.32. In the year 2000, what is the difference between the Mineral Rent(as % of GDP) of Oil and Mineral Rent(as % of GDP) of Other Minerals?
Keep it short and to the point. 2.82. In the year 2001, what is the difference between the Mineral Rent(as % of GDP) of Coal and Mineral Rent(as % of GDP) of Natural Gas?
Offer a very short reply. -2.31. In the year 2001, what is the difference between the Mineral Rent(as % of GDP) of Coal and Mineral Rent(as % of GDP) of Oil?
Ensure brevity in your answer.  -2.56. In the year 2001, what is the difference between the Mineral Rent(as % of GDP) in Coal and Mineral Rent(as % of GDP) in Other Minerals?
Offer a terse response. 0.22. In the year 2001, what is the difference between the Mineral Rent(as % of GDP) of Natural Gas and Mineral Rent(as % of GDP) of Oil?
Ensure brevity in your answer.  -0.25. In the year 2001, what is the difference between the Mineral Rent(as % of GDP) in Natural Gas and Mineral Rent(as % of GDP) in Other Minerals?
Make the answer very short. 2.52. In the year 2001, what is the difference between the Mineral Rent(as % of GDP) in Oil and Mineral Rent(as % of GDP) in Other Minerals?
Keep it short and to the point. 2.77. In the year 2002, what is the difference between the Mineral Rent(as % of GDP) in Coal and Mineral Rent(as % of GDP) in Natural Gas?
Your answer should be very brief. -1.5. In the year 2002, what is the difference between the Mineral Rent(as % of GDP) of Coal and Mineral Rent(as % of GDP) of Oil?
Ensure brevity in your answer.  -2.75. In the year 2002, what is the difference between the Mineral Rent(as % of GDP) in Coal and Mineral Rent(as % of GDP) in Other Minerals?
Keep it short and to the point. -0.03. In the year 2002, what is the difference between the Mineral Rent(as % of GDP) in Natural Gas and Mineral Rent(as % of GDP) in Oil?
Give a very brief answer. -1.25. In the year 2002, what is the difference between the Mineral Rent(as % of GDP) in Natural Gas and Mineral Rent(as % of GDP) in Other Minerals?
Provide a succinct answer. 1.47. In the year 2002, what is the difference between the Mineral Rent(as % of GDP) in Oil and Mineral Rent(as % of GDP) in Other Minerals?
Your answer should be compact. 2.71. In the year 2003, what is the difference between the Mineral Rent(as % of GDP) of Coal and Mineral Rent(as % of GDP) of Natural Gas?
Provide a short and direct response. -2.1. In the year 2003, what is the difference between the Mineral Rent(as % of GDP) in Coal and Mineral Rent(as % of GDP) in Oil?
Ensure brevity in your answer.  -2.67. In the year 2003, what is the difference between the Mineral Rent(as % of GDP) in Coal and Mineral Rent(as % of GDP) in Other Minerals?
Ensure brevity in your answer.  -0.05. In the year 2003, what is the difference between the Mineral Rent(as % of GDP) in Natural Gas and Mineral Rent(as % of GDP) in Oil?
Ensure brevity in your answer.  -0.58. In the year 2003, what is the difference between the Mineral Rent(as % of GDP) of Natural Gas and Mineral Rent(as % of GDP) of Other Minerals?
Your response must be concise. 2.04. In the year 2003, what is the difference between the Mineral Rent(as % of GDP) of Oil and Mineral Rent(as % of GDP) of Other Minerals?
Give a very brief answer. 2.62. What is the ratio of the Mineral Rent(as % of GDP) of Coal in 1997 to that in 1998?
Offer a terse response. 2.29. What is the ratio of the Mineral Rent(as % of GDP) of Natural Gas in 1997 to that in 1998?
Offer a very short reply. 1.63. What is the ratio of the Mineral Rent(as % of GDP) in Oil in 1997 to that in 1998?
Offer a very short reply. 2. What is the ratio of the Mineral Rent(as % of GDP) of Other Minerals in 1997 to that in 1998?
Keep it short and to the point. 2. What is the ratio of the Mineral Rent(as % of GDP) of Coal in 1997 to that in 1999?
Offer a very short reply. 4.62. What is the ratio of the Mineral Rent(as % of GDP) in Natural Gas in 1997 to that in 1999?
Provide a short and direct response. 1.58. What is the ratio of the Mineral Rent(as % of GDP) in Oil in 1997 to that in 1999?
Make the answer very short. 1.11. What is the ratio of the Mineral Rent(as % of GDP) of Other Minerals in 1997 to that in 1999?
Make the answer very short. 3.35. What is the ratio of the Mineral Rent(as % of GDP) in Coal in 1997 to that in 2000?
Your response must be concise. 2.41. What is the ratio of the Mineral Rent(as % of GDP) in Natural Gas in 1997 to that in 2000?
Offer a terse response. 0.72. What is the ratio of the Mineral Rent(as % of GDP) of Oil in 1997 to that in 2000?
Your answer should be very brief. 0.66. What is the ratio of the Mineral Rent(as % of GDP) in Other Minerals in 1997 to that in 2000?
Offer a very short reply. 1.48. What is the ratio of the Mineral Rent(as % of GDP) of Coal in 1997 to that in 2001?
Provide a succinct answer. 0.67. What is the ratio of the Mineral Rent(as % of GDP) in Natural Gas in 1997 to that in 2001?
Your answer should be compact. 0.66. What is the ratio of the Mineral Rent(as % of GDP) of Oil in 1997 to that in 2001?
Ensure brevity in your answer.  0.67. What is the ratio of the Mineral Rent(as % of GDP) of Other Minerals in 1997 to that in 2001?
Provide a short and direct response. 1.28. What is the ratio of the Mineral Rent(as % of GDP) in Coal in 1997 to that in 2002?
Provide a short and direct response. 1.65. What is the ratio of the Mineral Rent(as % of GDP) of Natural Gas in 1997 to that in 2002?
Offer a very short reply. 1.08. What is the ratio of the Mineral Rent(as % of GDP) in Oil in 1997 to that in 2002?
Provide a succinct answer. 0.67. What is the ratio of the Mineral Rent(as % of GDP) of Other Minerals in 1997 to that in 2002?
Provide a short and direct response. 1.13. What is the ratio of the Mineral Rent(as % of GDP) in Coal in 1997 to that in 2003?
Your answer should be very brief. 1.38. What is the ratio of the Mineral Rent(as % of GDP) of Natural Gas in 1997 to that in 2003?
Offer a terse response. 0.78. What is the ratio of the Mineral Rent(as % of GDP) in Oil in 1997 to that in 2003?
Give a very brief answer. 0.68. What is the ratio of the Mineral Rent(as % of GDP) of Other Minerals in 1997 to that in 2003?
Offer a terse response. 0.9. What is the ratio of the Mineral Rent(as % of GDP) in Coal in 1998 to that in 1999?
Give a very brief answer. 2.02. What is the ratio of the Mineral Rent(as % of GDP) in Natural Gas in 1998 to that in 1999?
Make the answer very short. 0.97. What is the ratio of the Mineral Rent(as % of GDP) of Oil in 1998 to that in 1999?
Provide a short and direct response. 0.56. What is the ratio of the Mineral Rent(as % of GDP) of Other Minerals in 1998 to that in 1999?
Give a very brief answer. 1.67. What is the ratio of the Mineral Rent(as % of GDP) in Coal in 1998 to that in 2000?
Your answer should be compact. 1.05. What is the ratio of the Mineral Rent(as % of GDP) in Natural Gas in 1998 to that in 2000?
Your answer should be compact. 0.44. What is the ratio of the Mineral Rent(as % of GDP) of Oil in 1998 to that in 2000?
Offer a terse response. 0.33. What is the ratio of the Mineral Rent(as % of GDP) of Other Minerals in 1998 to that in 2000?
Make the answer very short. 0.74. What is the ratio of the Mineral Rent(as % of GDP) in Coal in 1998 to that in 2001?
Your answer should be very brief. 0.29. What is the ratio of the Mineral Rent(as % of GDP) in Natural Gas in 1998 to that in 2001?
Your answer should be compact. 0.41. What is the ratio of the Mineral Rent(as % of GDP) in Other Minerals in 1998 to that in 2001?
Ensure brevity in your answer.  0.64. What is the ratio of the Mineral Rent(as % of GDP) of Coal in 1998 to that in 2002?
Give a very brief answer. 0.72. What is the ratio of the Mineral Rent(as % of GDP) in Natural Gas in 1998 to that in 2002?
Offer a terse response. 0.66. What is the ratio of the Mineral Rent(as % of GDP) in Oil in 1998 to that in 2002?
Provide a short and direct response. 0.34. What is the ratio of the Mineral Rent(as % of GDP) of Other Minerals in 1998 to that in 2002?
Give a very brief answer. 0.56. What is the ratio of the Mineral Rent(as % of GDP) of Coal in 1998 to that in 2003?
Ensure brevity in your answer.  0.6. What is the ratio of the Mineral Rent(as % of GDP) of Natural Gas in 1998 to that in 2003?
Offer a terse response. 0.48. What is the ratio of the Mineral Rent(as % of GDP) of Oil in 1998 to that in 2003?
Offer a very short reply. 0.34. What is the ratio of the Mineral Rent(as % of GDP) of Other Minerals in 1998 to that in 2003?
Ensure brevity in your answer.  0.45. What is the ratio of the Mineral Rent(as % of GDP) in Coal in 1999 to that in 2000?
Offer a very short reply. 0.52. What is the ratio of the Mineral Rent(as % of GDP) in Natural Gas in 1999 to that in 2000?
Your answer should be very brief. 0.46. What is the ratio of the Mineral Rent(as % of GDP) in Oil in 1999 to that in 2000?
Provide a short and direct response. 0.6. What is the ratio of the Mineral Rent(as % of GDP) in Other Minerals in 1999 to that in 2000?
Offer a very short reply. 0.44. What is the ratio of the Mineral Rent(as % of GDP) in Coal in 1999 to that in 2001?
Offer a very short reply. 0.14. What is the ratio of the Mineral Rent(as % of GDP) in Natural Gas in 1999 to that in 2001?
Offer a terse response. 0.42. What is the ratio of the Mineral Rent(as % of GDP) in Oil in 1999 to that in 2001?
Ensure brevity in your answer.  0.6. What is the ratio of the Mineral Rent(as % of GDP) of Other Minerals in 1999 to that in 2001?
Your response must be concise. 0.38. What is the ratio of the Mineral Rent(as % of GDP) of Coal in 1999 to that in 2002?
Make the answer very short. 0.36. What is the ratio of the Mineral Rent(as % of GDP) in Natural Gas in 1999 to that in 2002?
Provide a short and direct response. 0.68. What is the ratio of the Mineral Rent(as % of GDP) in Oil in 1999 to that in 2002?
Give a very brief answer. 0.61. What is the ratio of the Mineral Rent(as % of GDP) in Other Minerals in 1999 to that in 2002?
Provide a succinct answer. 0.34. What is the ratio of the Mineral Rent(as % of GDP) in Coal in 1999 to that in 2003?
Offer a very short reply. 0.3. What is the ratio of the Mineral Rent(as % of GDP) of Natural Gas in 1999 to that in 2003?
Offer a terse response. 0.49. What is the ratio of the Mineral Rent(as % of GDP) in Oil in 1999 to that in 2003?
Keep it short and to the point. 0.62. What is the ratio of the Mineral Rent(as % of GDP) of Other Minerals in 1999 to that in 2003?
Make the answer very short. 0.27. What is the ratio of the Mineral Rent(as % of GDP) in Coal in 2000 to that in 2001?
Offer a terse response. 0.28. What is the ratio of the Mineral Rent(as % of GDP) of Natural Gas in 2000 to that in 2001?
Ensure brevity in your answer.  0.92. What is the ratio of the Mineral Rent(as % of GDP) in Oil in 2000 to that in 2001?
Offer a terse response. 1.01. What is the ratio of the Mineral Rent(as % of GDP) in Other Minerals in 2000 to that in 2001?
Your answer should be compact. 0.87. What is the ratio of the Mineral Rent(as % of GDP) in Coal in 2000 to that in 2002?
Provide a short and direct response. 0.68. What is the ratio of the Mineral Rent(as % of GDP) of Natural Gas in 2000 to that in 2002?
Ensure brevity in your answer.  1.49. What is the ratio of the Mineral Rent(as % of GDP) of Oil in 2000 to that in 2002?
Provide a short and direct response. 1.02. What is the ratio of the Mineral Rent(as % of GDP) in Other Minerals in 2000 to that in 2002?
Keep it short and to the point. 0.77. What is the ratio of the Mineral Rent(as % of GDP) in Coal in 2000 to that in 2003?
Provide a short and direct response. 0.57. What is the ratio of the Mineral Rent(as % of GDP) of Natural Gas in 2000 to that in 2003?
Provide a succinct answer. 1.08. What is the ratio of the Mineral Rent(as % of GDP) in Oil in 2000 to that in 2003?
Provide a short and direct response. 1.04. What is the ratio of the Mineral Rent(as % of GDP) in Other Minerals in 2000 to that in 2003?
Give a very brief answer. 0.61. What is the ratio of the Mineral Rent(as % of GDP) in Coal in 2001 to that in 2002?
Provide a succinct answer. 2.46. What is the ratio of the Mineral Rent(as % of GDP) in Natural Gas in 2001 to that in 2002?
Offer a very short reply. 1.63. What is the ratio of the Mineral Rent(as % of GDP) of Oil in 2001 to that in 2002?
Your answer should be very brief. 1.01. What is the ratio of the Mineral Rent(as % of GDP) of Other Minerals in 2001 to that in 2002?
Provide a succinct answer. 0.88. What is the ratio of the Mineral Rent(as % of GDP) in Coal in 2001 to that in 2003?
Give a very brief answer. 2.06. What is the ratio of the Mineral Rent(as % of GDP) in Natural Gas in 2001 to that in 2003?
Your answer should be compact. 1.18. What is the ratio of the Mineral Rent(as % of GDP) in Oil in 2001 to that in 2003?
Your answer should be very brief. 1.03. What is the ratio of the Mineral Rent(as % of GDP) of Other Minerals in 2001 to that in 2003?
Your answer should be very brief. 0.7. What is the ratio of the Mineral Rent(as % of GDP) of Coal in 2002 to that in 2003?
Provide a short and direct response. 0.84. What is the ratio of the Mineral Rent(as % of GDP) of Natural Gas in 2002 to that in 2003?
Give a very brief answer. 0.73. What is the ratio of the Mineral Rent(as % of GDP) in Oil in 2002 to that in 2003?
Ensure brevity in your answer.  1.01. What is the ratio of the Mineral Rent(as % of GDP) of Other Minerals in 2002 to that in 2003?
Offer a terse response. 0.79. What is the difference between the highest and the second highest Mineral Rent(as % of GDP) in Coal?
Offer a terse response. 0.13. What is the difference between the highest and the second highest Mineral Rent(as % of GDP) of Natural Gas?
Keep it short and to the point. 0.22. What is the difference between the highest and the second highest Mineral Rent(as % of GDP) in Oil?
Offer a very short reply. 0.02. What is the difference between the highest and the second highest Mineral Rent(as % of GDP) in Other Minerals?
Your response must be concise. 0.02. What is the difference between the highest and the lowest Mineral Rent(as % of GDP) in Coal?
Your answer should be very brief. 0.33. What is the difference between the highest and the lowest Mineral Rent(as % of GDP) in Natural Gas?
Your response must be concise. 1.6. What is the difference between the highest and the lowest Mineral Rent(as % of GDP) of Oil?
Your response must be concise. 1.98. What is the difference between the highest and the lowest Mineral Rent(as % of GDP) of Other Minerals?
Your answer should be compact. 0.17. 